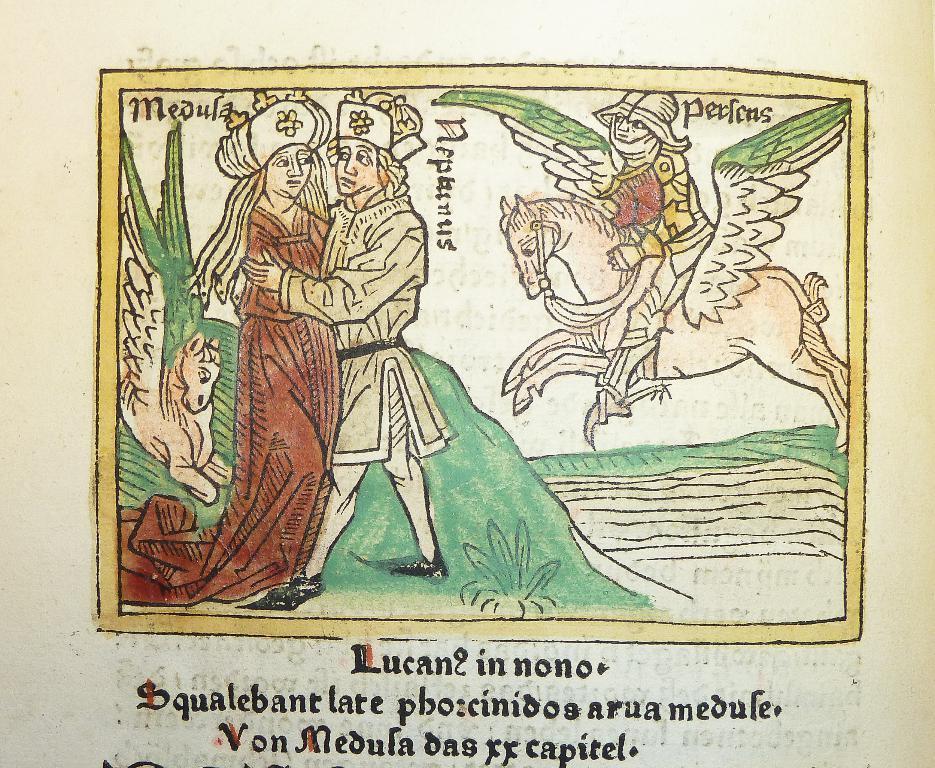How would you summarize this image in a sentence or two? In this picture there is a text on the paper and there is a picture of a man standing and holding the woman and there is a person sitting on the horse and there are two horses and it has wings and there is a text and there is water and there is a plant. 